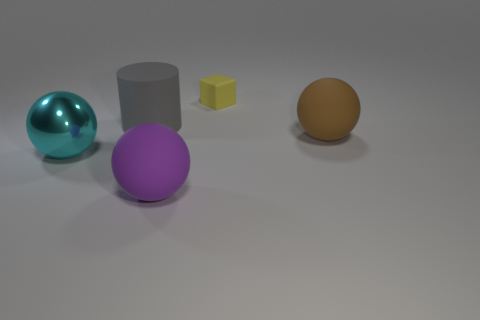Can you describe the lighting and shadows present in the image? The image features soft, diffuse lighting that creates gentle shadows beneath each object. The lighting angle appears to be from the upper left, as indicated by the longer shadows cast to the lower right of each object. The shadows are relatively soft-edged, suggesting the light source is not extremely close to the objects or exceedingly intense. Each object's shadow aligns with the others, which adds to the sense of coherency in the scene's illumination. 